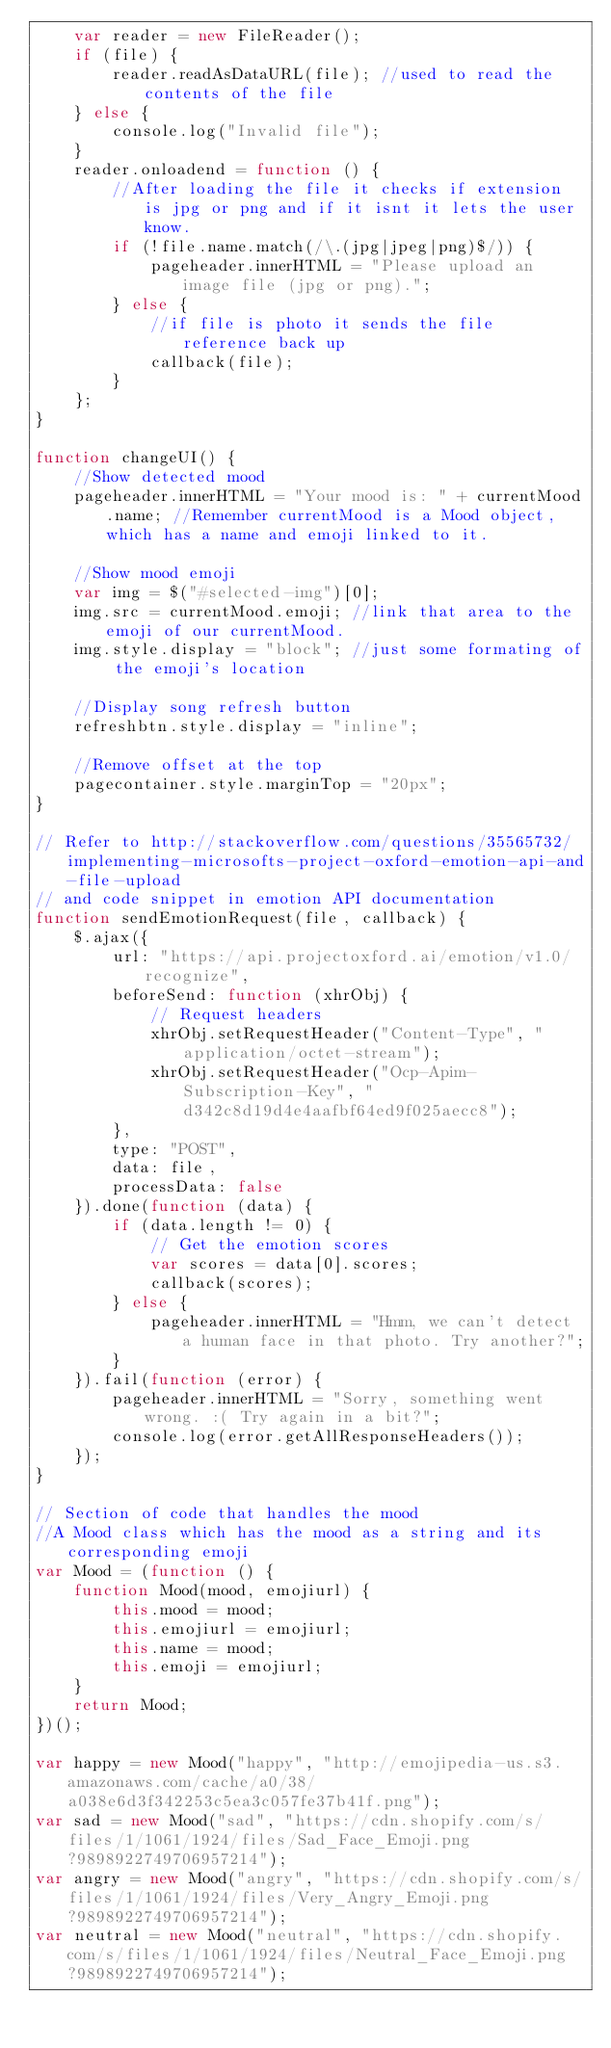<code> <loc_0><loc_0><loc_500><loc_500><_JavaScript_>    var reader = new FileReader();
    if (file) {
        reader.readAsDataURL(file); //used to read the contents of the file
    } else {
        console.log("Invalid file");
    }
    reader.onloadend = function () {
        //After loading the file it checks if extension is jpg or png and if it isnt it lets the user know.
        if (!file.name.match(/\.(jpg|jpeg|png)$/)) {
            pageheader.innerHTML = "Please upload an image file (jpg or png).";
        } else {
            //if file is photo it sends the file reference back up
            callback(file);
        }
    };
}

function changeUI() {
    //Show detected mood
    pageheader.innerHTML = "Your mood is: " + currentMood.name; //Remember currentMood is a Mood object, which has a name and emoji linked to it.

    //Show mood emoji
    var img = $("#selected-img")[0];
    img.src = currentMood.emoji; //link that area to the emoji of our currentMood.
    img.style.display = "block"; //just some formating of the emoji's location

    //Display song refresh button
    refreshbtn.style.display = "inline";

    //Remove offset at the top
    pagecontainer.style.marginTop = "20px";
}

// Refer to http://stackoverflow.com/questions/35565732/implementing-microsofts-project-oxford-emotion-api-and-file-upload
// and code snippet in emotion API documentation
function sendEmotionRequest(file, callback) {
    $.ajax({
        url: "https://api.projectoxford.ai/emotion/v1.0/recognize",
        beforeSend: function (xhrObj) {
            // Request headers
            xhrObj.setRequestHeader("Content-Type", "application/octet-stream");
            xhrObj.setRequestHeader("Ocp-Apim-Subscription-Key", "d342c8d19d4e4aafbf64ed9f025aecc8");
        },
        type: "POST",
        data: file,
        processData: false
    }).done(function (data) {
        if (data.length != 0) {
            // Get the emotion scores
            var scores = data[0].scores;
            callback(scores);
        } else {
            pageheader.innerHTML = "Hmm, we can't detect a human face in that photo. Try another?";
        }
    }).fail(function (error) {
        pageheader.innerHTML = "Sorry, something went wrong. :( Try again in a bit?";
        console.log(error.getAllResponseHeaders());
    });
}

// Section of code that handles the mood
//A Mood class which has the mood as a string and its corresponding emoji
var Mood = (function () {
    function Mood(mood, emojiurl) {
        this.mood = mood;
        this.emojiurl = emojiurl;
        this.name = mood;
        this.emoji = emojiurl;
    }
    return Mood;
})();

var happy = new Mood("happy", "http://emojipedia-us.s3.amazonaws.com/cache/a0/38/a038e6d3f342253c5ea3c057fe37b41f.png");
var sad = new Mood("sad", "https://cdn.shopify.com/s/files/1/1061/1924/files/Sad_Face_Emoji.png?9898922749706957214");
var angry = new Mood("angry", "https://cdn.shopify.com/s/files/1/1061/1924/files/Very_Angry_Emoji.png?9898922749706957214");
var neutral = new Mood("neutral", "https://cdn.shopify.com/s/files/1/1061/1924/files/Neutral_Face_Emoji.png?9898922749706957214");
</code> 